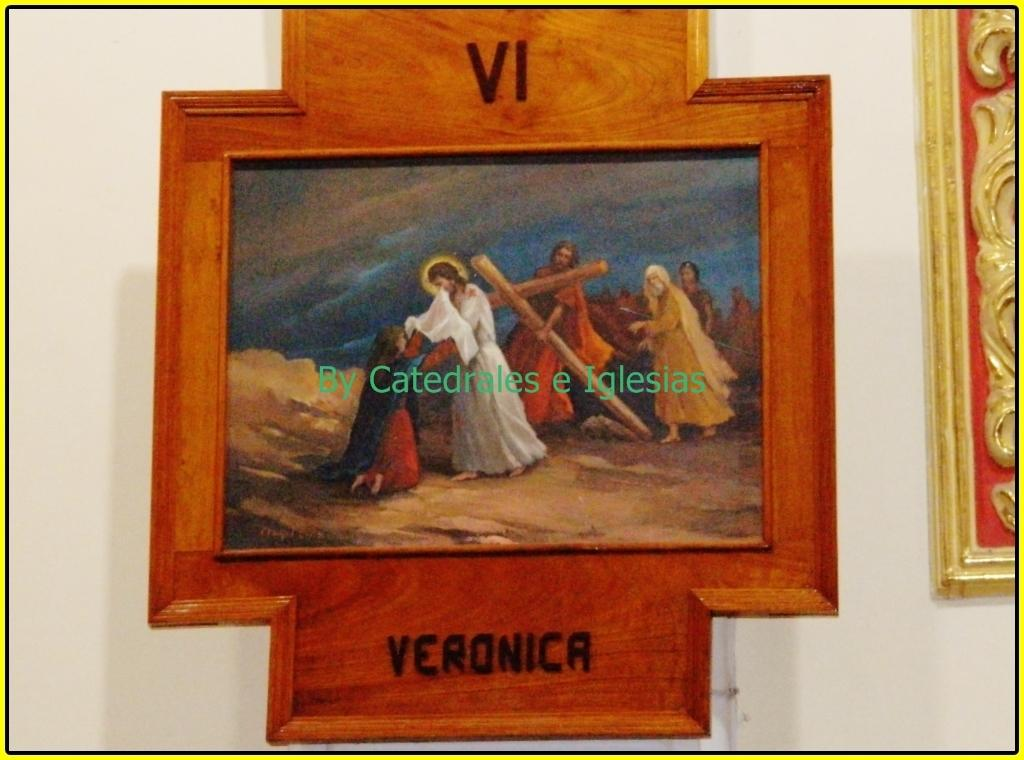<image>
Relay a brief, clear account of the picture shown. A religious  picture in an odd frame that says Veronica on the bottom. 